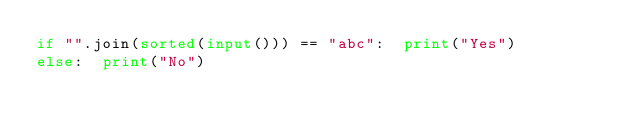<code> <loc_0><loc_0><loc_500><loc_500><_Python_>if "".join(sorted(input())) == "abc":  print("Yes")
else:  print("No")</code> 